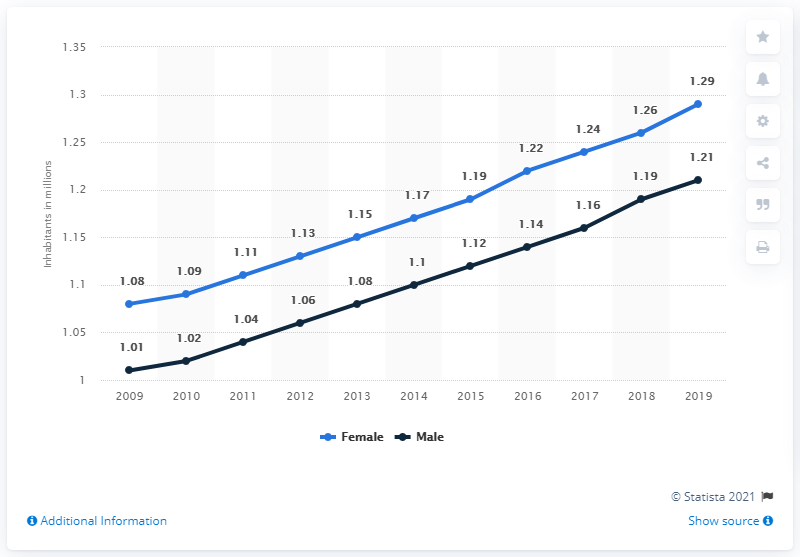Mention a couple of crucial points in this snapshot. In 2019, Namibia's female population was 1.29 million. The average of 2013 and 2014 is 2.25. Namibia's male population in 2019 was 1,210,000. The chart represents approximately 11 years of population data. 